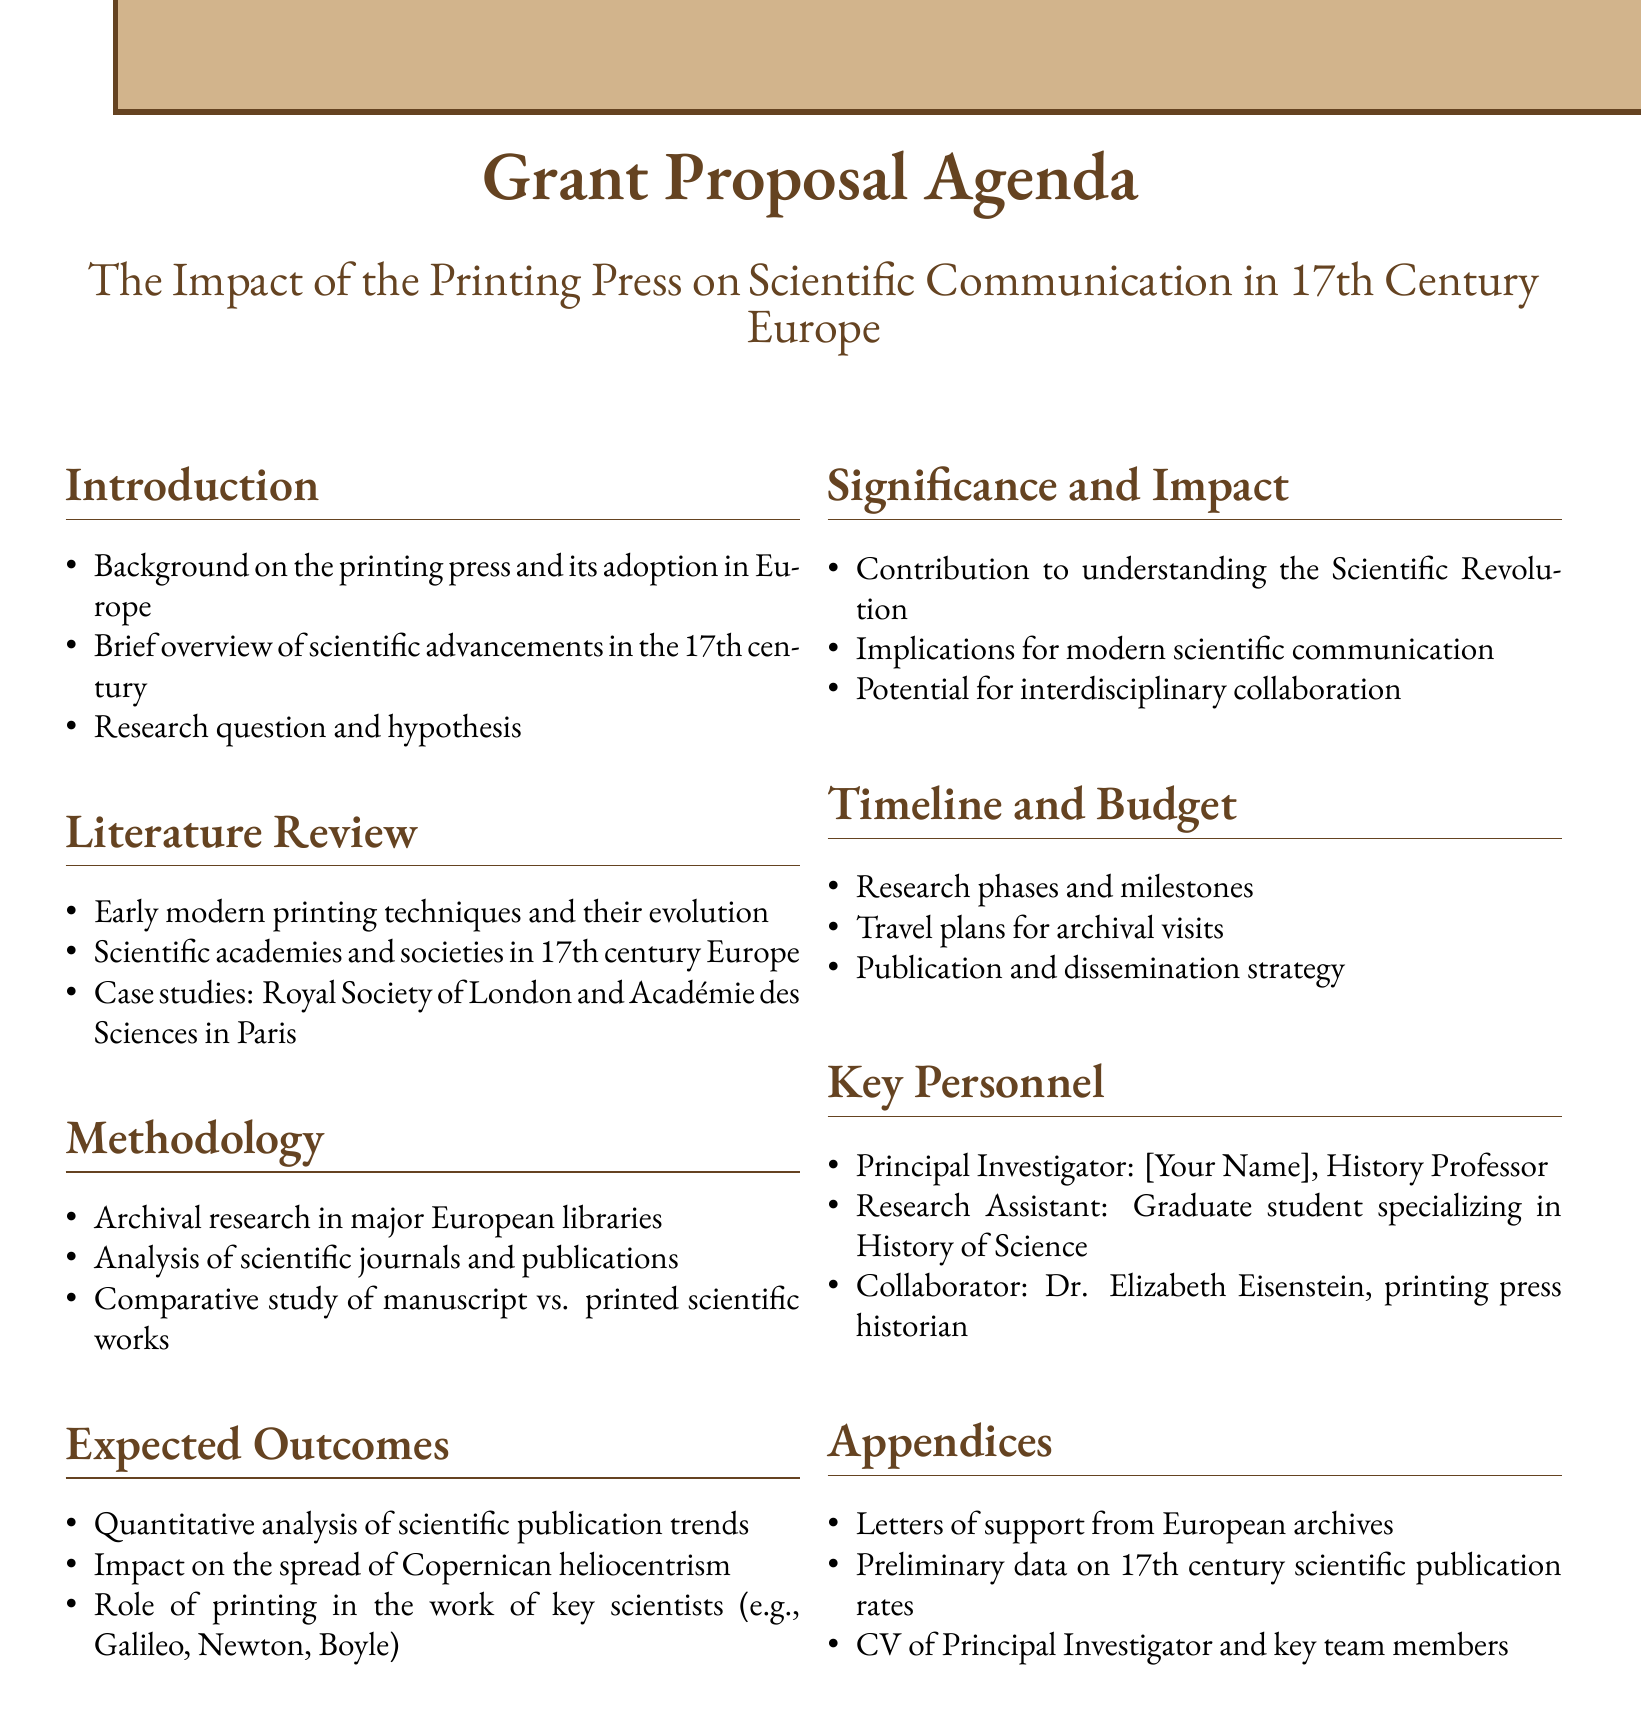What is the title of the grant proposal? The title is provided at the beginning of the document, summarizing the main focus of the proposal.
Answer: The Impact of the Printing Press on Scientific Communication in 17th Century Europe Who is the Principal Investigator? This information is found in the Key Personnel section, which lists the main contributors to the project.
Answer: [Your Name] What is one of the case studies mentioned in the Literature Review? The Literature Review includes specific examples of scientific societies that are analyzed within the proposal.
Answer: Royal Society of London What type of research is proposed in the Methodology section? The Methodology lists various types of research that will be conducted to answer the research question.
Answer: Archival research What is one expected outcome of the research? The Expected Outcomes section outlines the anticipated results of the research efforts and their impact.
Answer: Impact on the spread of Copernican heliocentrism What contribution is stated under Significance and Impact? This part of the document emphasizes the importance of the research in a broader scientific and historical context.
Answer: Contribution to understanding the Scientific Revolution What is mentioned as part of the Timeline and Budget? The Timeline and Budget section outlines the research phases and support necessary for the project.
Answer: Research phases and milestones Who is a collaborator mentioned in the Key Personnel section? The Key Personnel section not only lists the principal investigator but also includes collaborators contributing expertise.
Answer: Dr. Elizabeth Eisenstein 